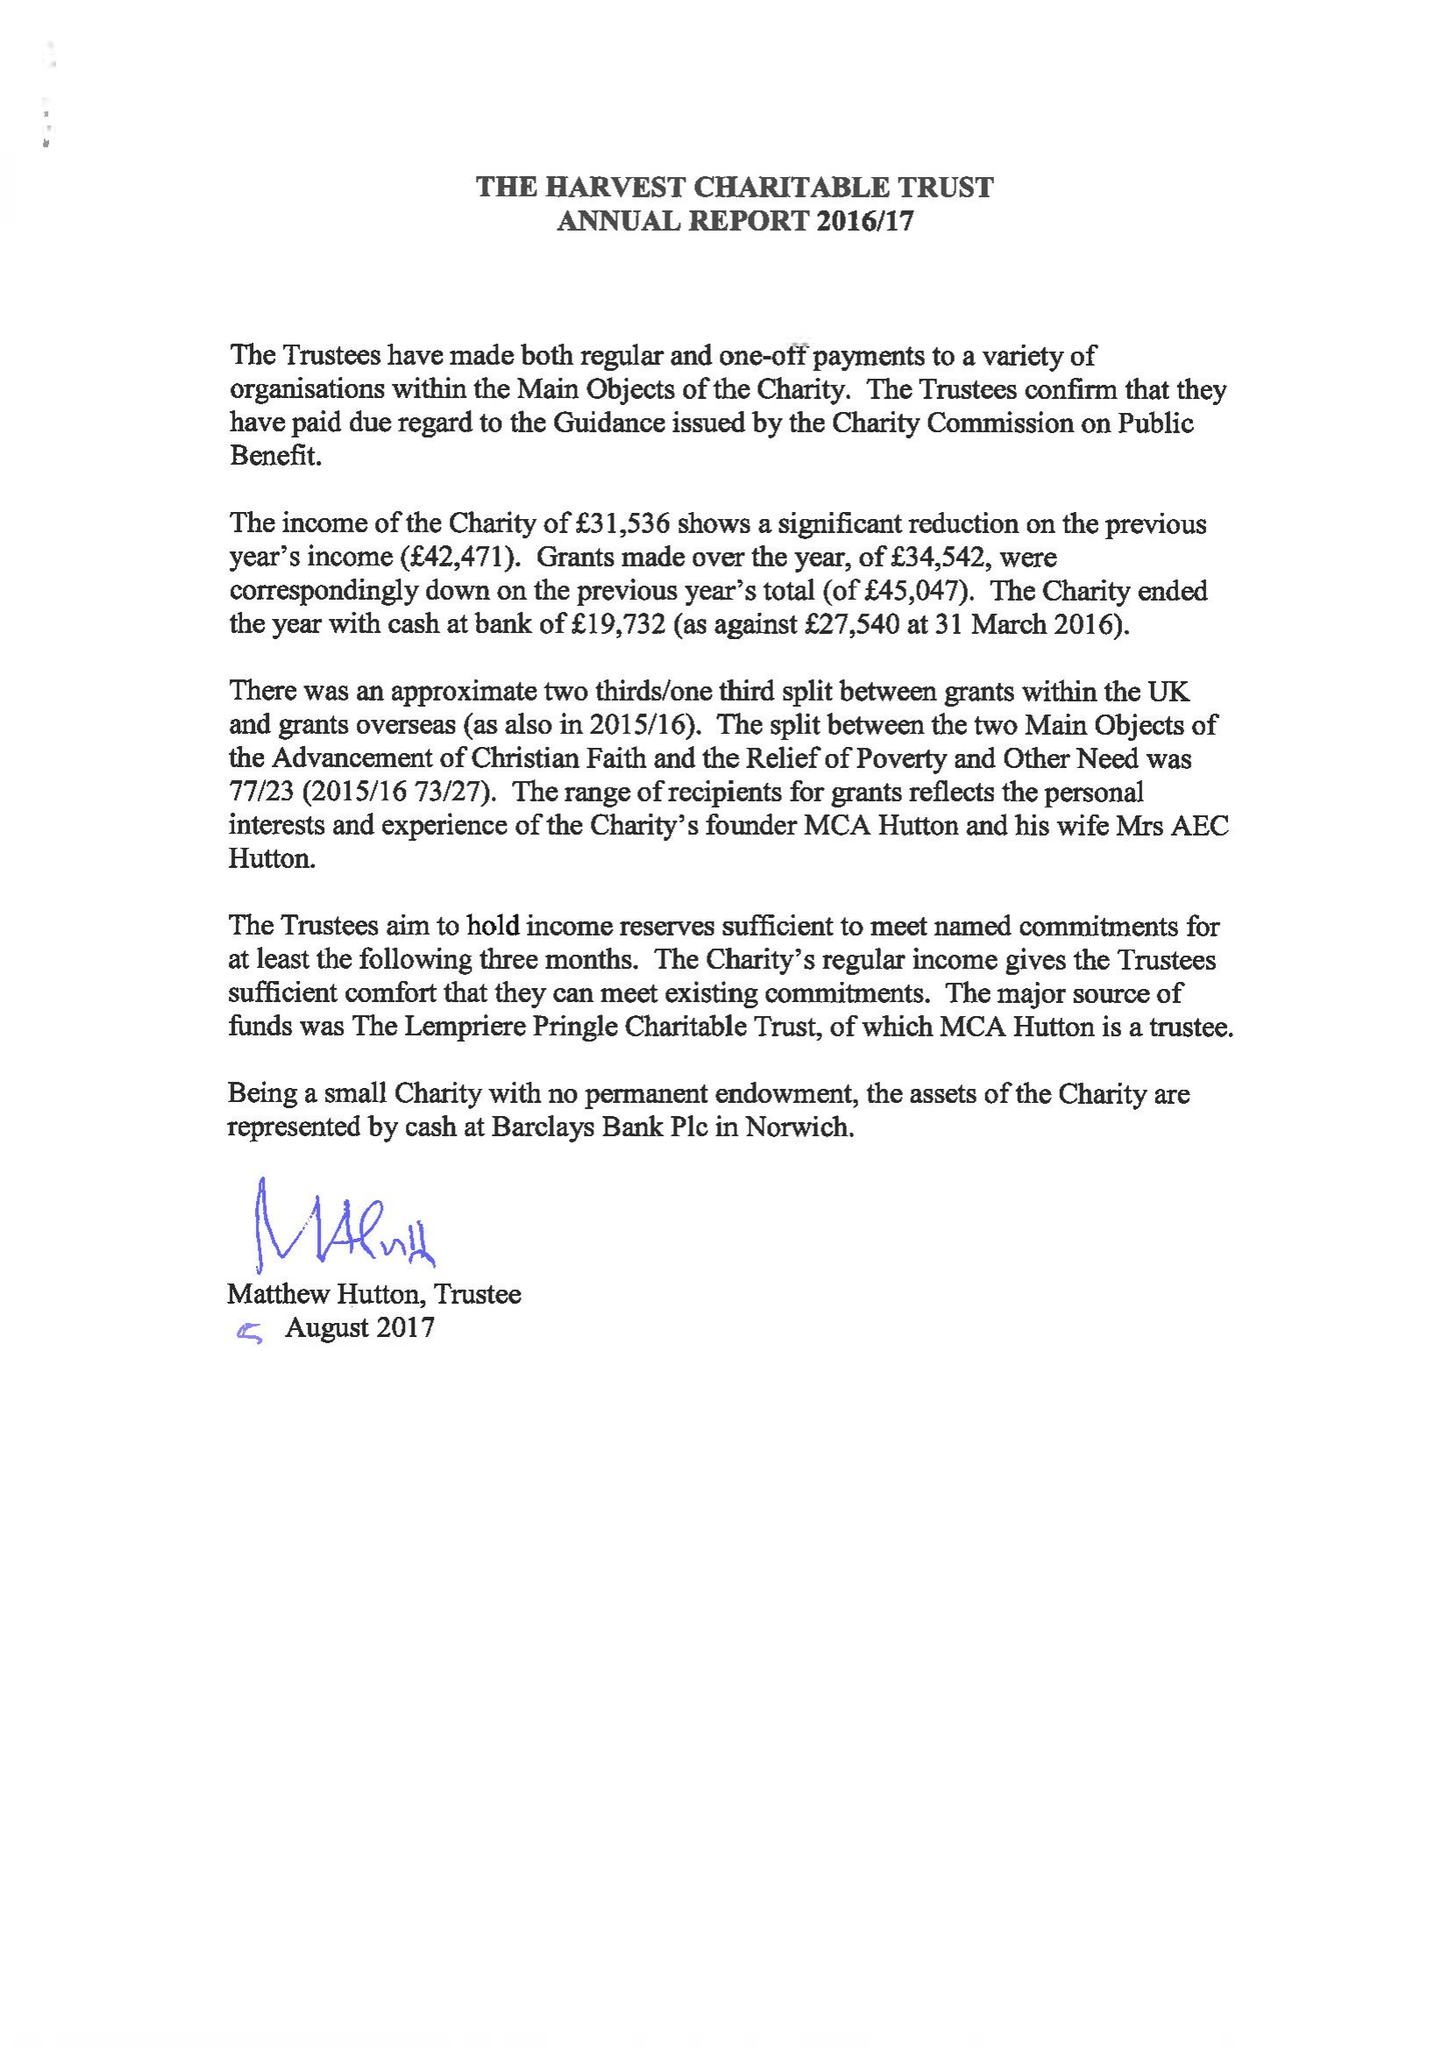What is the value for the report_date?
Answer the question using a single word or phrase. 2017-03-31 